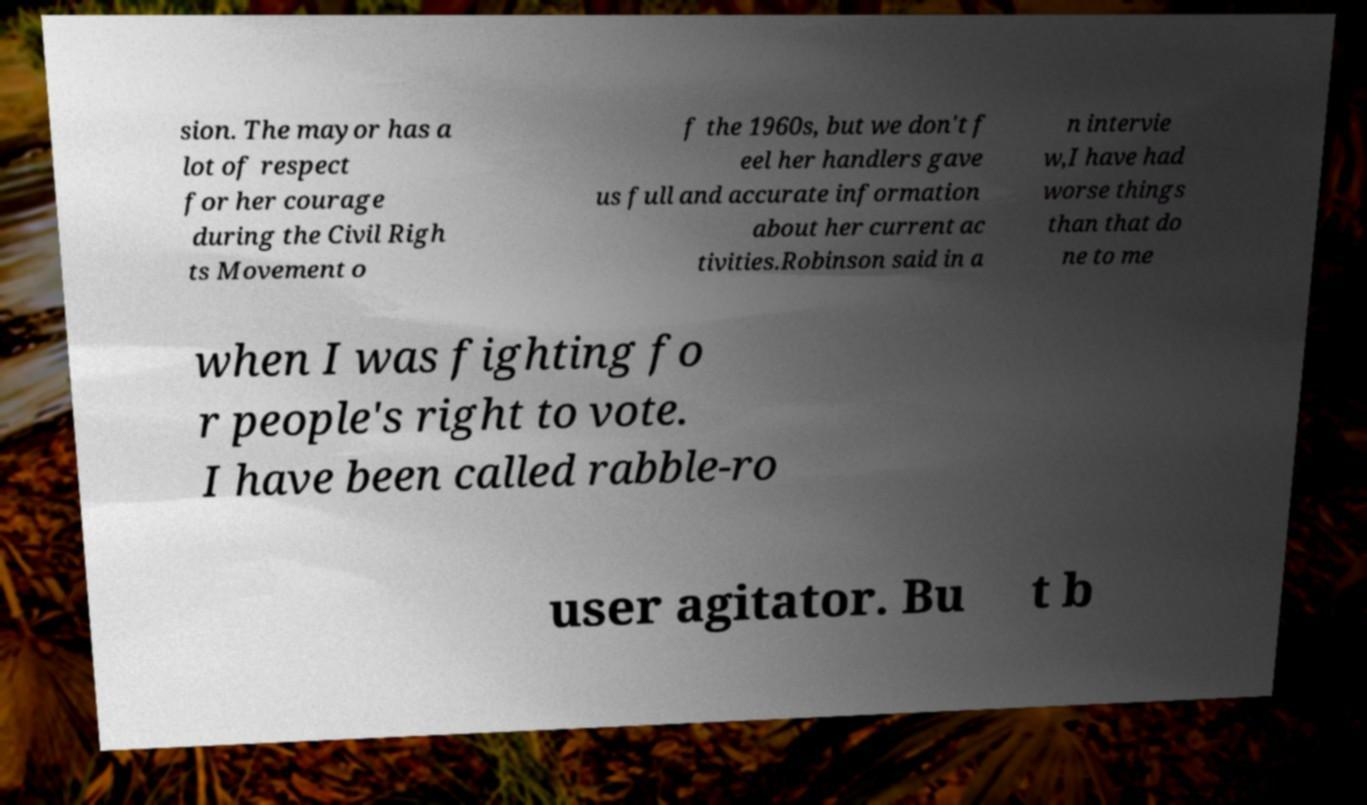Can you accurately transcribe the text from the provided image for me? sion. The mayor has a lot of respect for her courage during the Civil Righ ts Movement o f the 1960s, but we don't f eel her handlers gave us full and accurate information about her current ac tivities.Robinson said in a n intervie w,I have had worse things than that do ne to me when I was fighting fo r people's right to vote. I have been called rabble-ro user agitator. Bu t b 